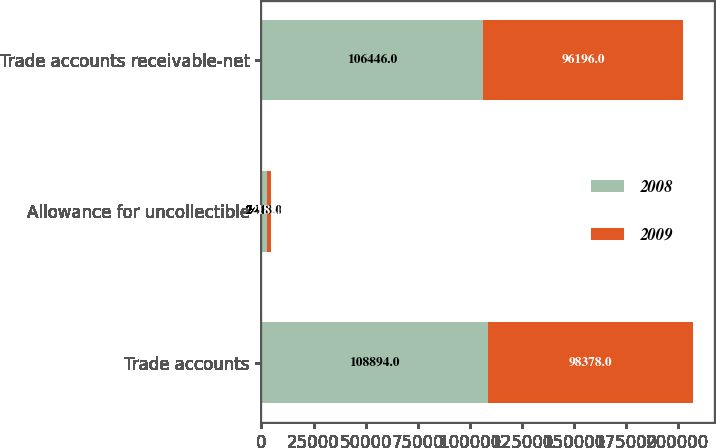Convert chart. <chart><loc_0><loc_0><loc_500><loc_500><stacked_bar_chart><ecel><fcel>Trade accounts<fcel>Allowance for uncollectible<fcel>Trade accounts receivable-net<nl><fcel>2008<fcel>108894<fcel>2448<fcel>106446<nl><fcel>2009<fcel>98378<fcel>2182<fcel>96196<nl></chart> 